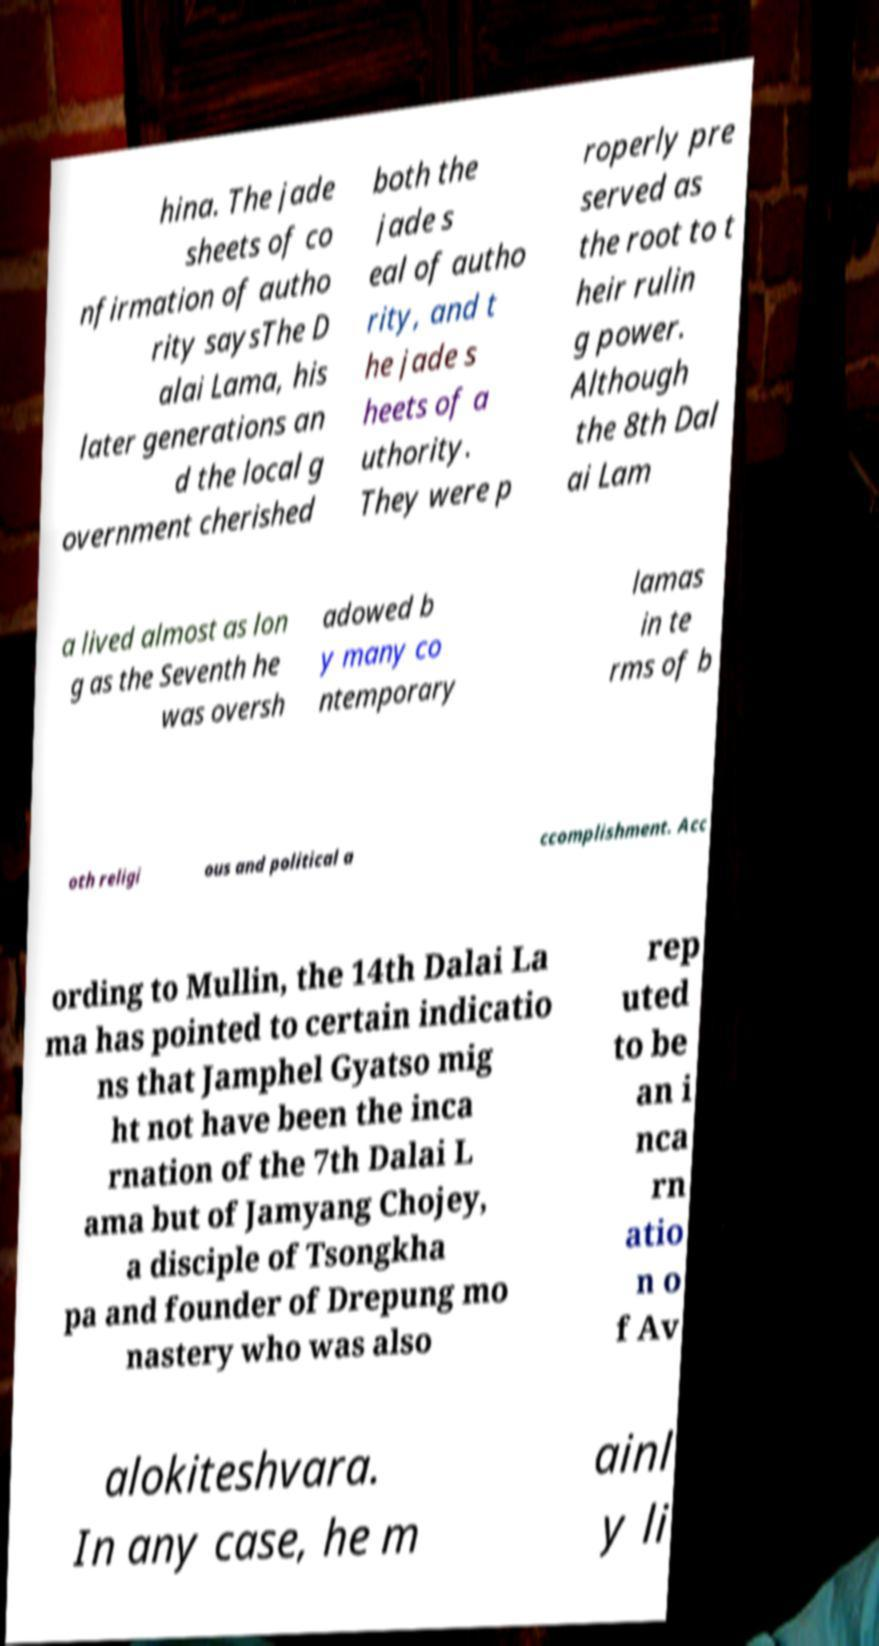For documentation purposes, I need the text within this image transcribed. Could you provide that? hina. The jade sheets of co nfirmation of autho rity saysThe D alai Lama, his later generations an d the local g overnment cherished both the jade s eal of autho rity, and t he jade s heets of a uthority. They were p roperly pre served as the root to t heir rulin g power. Although the 8th Dal ai Lam a lived almost as lon g as the Seventh he was oversh adowed b y many co ntemporary lamas in te rms of b oth religi ous and political a ccomplishment. Acc ording to Mullin, the 14th Dalai La ma has pointed to certain indicatio ns that Jamphel Gyatso mig ht not have been the inca rnation of the 7th Dalai L ama but of Jamyang Chojey, a disciple of Tsongkha pa and founder of Drepung mo nastery who was also rep uted to be an i nca rn atio n o f Av alokiteshvara. In any case, he m ainl y li 